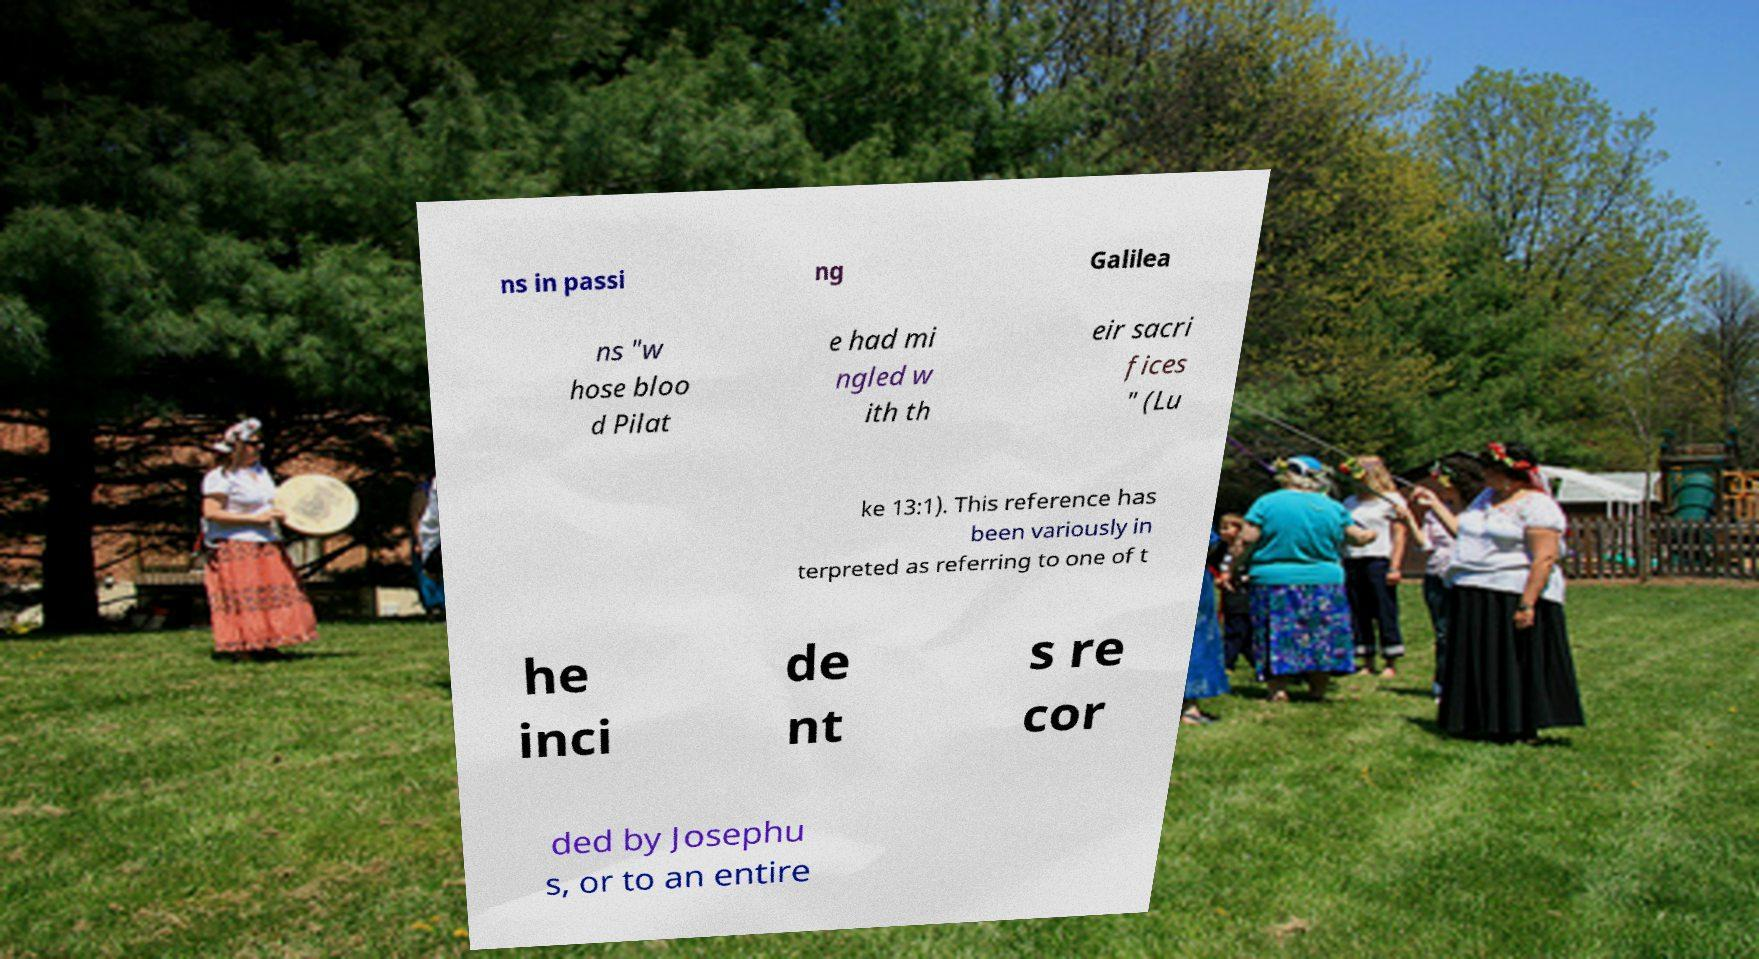Please read and relay the text visible in this image. What does it say? ns in passi ng Galilea ns "w hose bloo d Pilat e had mi ngled w ith th eir sacri fices " (Lu ke 13:1). This reference has been variously in terpreted as referring to one of t he inci de nt s re cor ded by Josephu s, or to an entire 